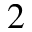<formula> <loc_0><loc_0><loc_500><loc_500>_ { 2 }</formula> 